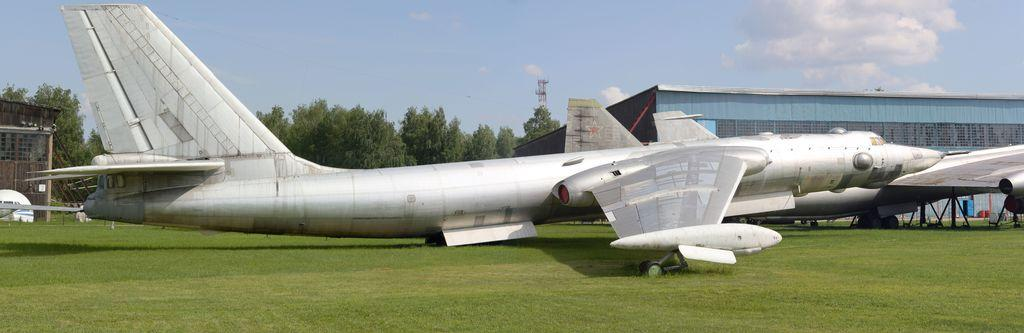What can be seen on the grass in the image? There are aeroplanes on the grass in the image. What is visible in the background of the image? There are trees, buildings, poles, objects, and a tower in the background of the image. Additionally, there are clouds in the sky in the background of the image. How does the love between the aeroplanes manifest in the image? There is no indication of love between the aeroplanes in the image, as they are inanimate objects. 